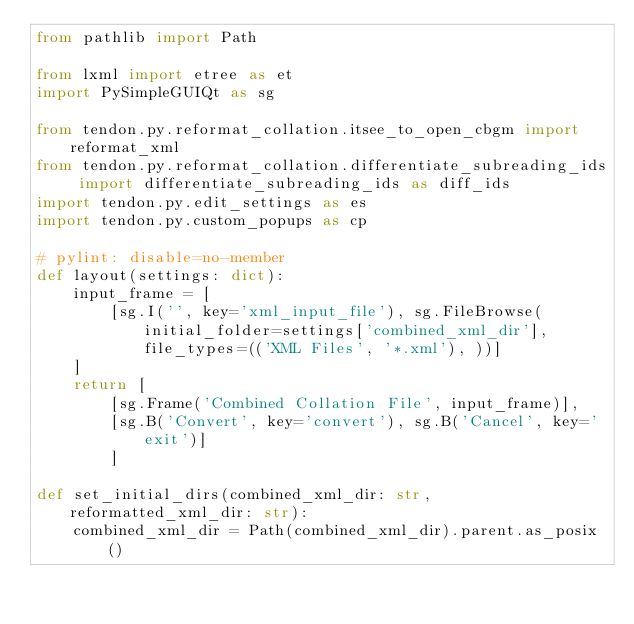<code> <loc_0><loc_0><loc_500><loc_500><_Python_>from pathlib import Path

from lxml import etree as et
import PySimpleGUIQt as sg

from tendon.py.reformat_collation.itsee_to_open_cbgm import reformat_xml
from tendon.py.reformat_collation.differentiate_subreading_ids import differentiate_subreading_ids as diff_ids
import tendon.py.edit_settings as es
import tendon.py.custom_popups as cp

# pylint: disable=no-member
def layout(settings: dict):
    input_frame = [
        [sg.I('', key='xml_input_file'), sg.FileBrowse(initial_folder=settings['combined_xml_dir'], file_types=(('XML Files', '*.xml'), ))]
    ]
    return [
        [sg.Frame('Combined Collation File', input_frame)],
        [sg.B('Convert', key='convert'), sg.B('Cancel', key='exit')]
        ]

def set_initial_dirs(combined_xml_dir: str, reformatted_xml_dir: str):
    combined_xml_dir = Path(combined_xml_dir).parent.as_posix()</code> 